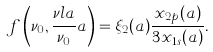<formula> <loc_0><loc_0><loc_500><loc_500>f \left ( \nu _ { 0 } , \frac { \nu l a } { \nu _ { 0 } } a \right ) = \xi _ { 2 } ( a ) \frac { x _ { 2 p } ( a ) } { 3 x _ { 1 s } ( a ) } .</formula> 